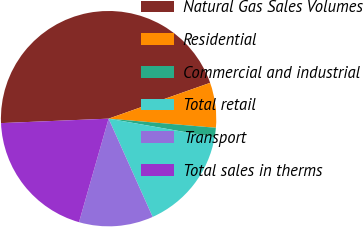Convert chart to OTSL. <chart><loc_0><loc_0><loc_500><loc_500><pie_chart><fcel>Natural Gas Sales Volumes<fcel>Residential<fcel>Commercial and industrial<fcel>Total retail<fcel>Transport<fcel>Total sales in therms<nl><fcel>45.26%<fcel>6.75%<fcel>1.42%<fcel>15.52%<fcel>11.14%<fcel>19.91%<nl></chart> 